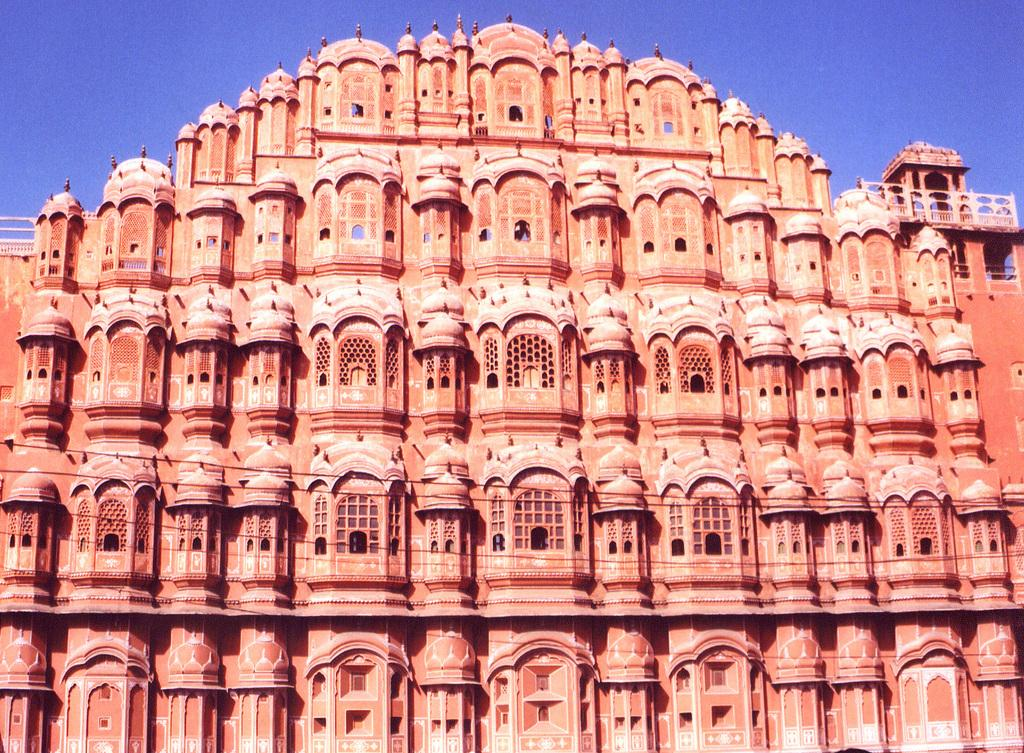What type of structure is present in the image? There is a building in the image. What can be seen in the background of the image? The sky is visible in the background of the image. What type of jar is visible on the roof of the building in the image? There is no jar visible on the roof of the building in the image. 